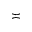Convert formula to latex. <formula><loc_0><loc_0><loc_500><loc_500>\asymp</formula> 